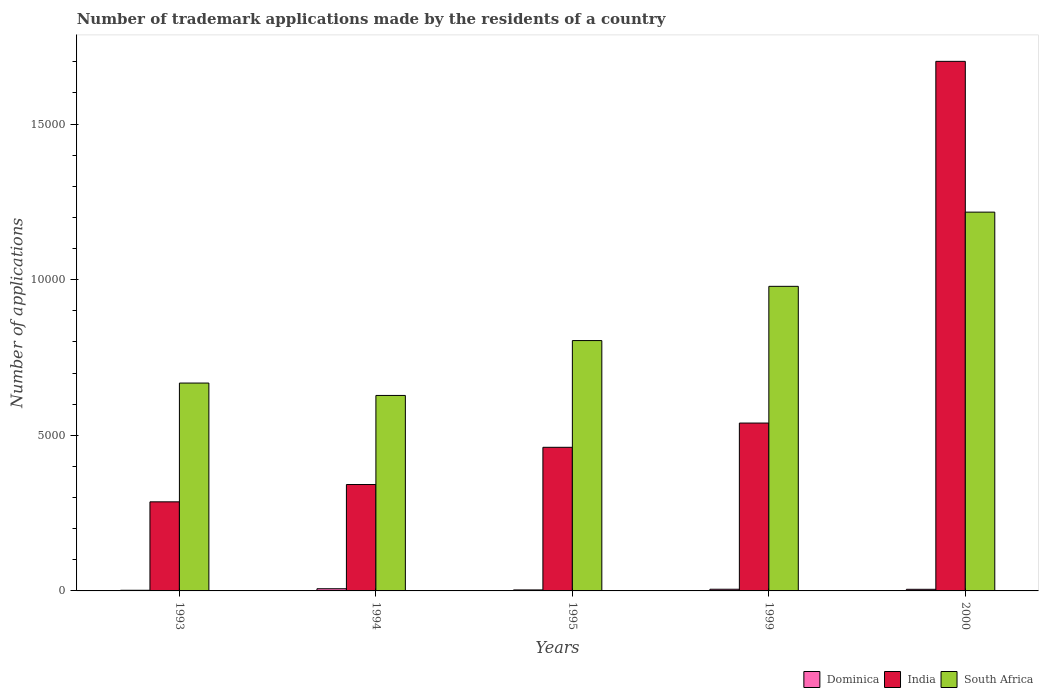How many groups of bars are there?
Offer a terse response. 5. Are the number of bars per tick equal to the number of legend labels?
Your response must be concise. Yes. Are the number of bars on each tick of the X-axis equal?
Your response must be concise. Yes. How many bars are there on the 3rd tick from the left?
Provide a succinct answer. 3. How many bars are there on the 5th tick from the right?
Your response must be concise. 3. What is the label of the 4th group of bars from the left?
Ensure brevity in your answer.  1999. What is the number of trademark applications made by the residents in India in 1995?
Your answer should be very brief. 4614. Across all years, what is the maximum number of trademark applications made by the residents in India?
Provide a succinct answer. 1.70e+04. Across all years, what is the minimum number of trademark applications made by the residents in Dominica?
Your answer should be very brief. 21. What is the total number of trademark applications made by the residents in India in the graph?
Keep it short and to the point. 3.33e+04. What is the difference between the number of trademark applications made by the residents in India in 1994 and that in 2000?
Keep it short and to the point. -1.36e+04. What is the difference between the number of trademark applications made by the residents in South Africa in 1993 and the number of trademark applications made by the residents in India in 1994?
Offer a terse response. 3260. What is the average number of trademark applications made by the residents in Dominica per year?
Give a very brief answer. 45.8. In the year 1994, what is the difference between the number of trademark applications made by the residents in India and number of trademark applications made by the residents in South Africa?
Keep it short and to the point. -2862. Is the number of trademark applications made by the residents in India in 1999 less than that in 2000?
Your answer should be compact. Yes. What is the difference between the highest and the second highest number of trademark applications made by the residents in India?
Make the answer very short. 1.16e+04. In how many years, is the number of trademark applications made by the residents in South Africa greater than the average number of trademark applications made by the residents in South Africa taken over all years?
Offer a very short reply. 2. Is the sum of the number of trademark applications made by the residents in South Africa in 1995 and 1999 greater than the maximum number of trademark applications made by the residents in India across all years?
Ensure brevity in your answer.  Yes. What does the 3rd bar from the right in 1999 represents?
Offer a terse response. Dominica. How many bars are there?
Your answer should be compact. 15. Are all the bars in the graph horizontal?
Offer a very short reply. No. How many years are there in the graph?
Your answer should be very brief. 5. Does the graph contain any zero values?
Offer a very short reply. No. Does the graph contain grids?
Provide a short and direct response. No. Where does the legend appear in the graph?
Your answer should be very brief. Bottom right. How are the legend labels stacked?
Give a very brief answer. Horizontal. What is the title of the graph?
Your answer should be compact. Number of trademark applications made by the residents of a country. Does "Libya" appear as one of the legend labels in the graph?
Ensure brevity in your answer.  No. What is the label or title of the Y-axis?
Keep it short and to the point. Number of applications. What is the Number of applications in Dominica in 1993?
Your answer should be very brief. 21. What is the Number of applications of India in 1993?
Give a very brief answer. 2862. What is the Number of applications in South Africa in 1993?
Ensure brevity in your answer.  6678. What is the Number of applications in India in 1994?
Make the answer very short. 3418. What is the Number of applications of South Africa in 1994?
Ensure brevity in your answer.  6280. What is the Number of applications in India in 1995?
Give a very brief answer. 4614. What is the Number of applications in South Africa in 1995?
Provide a succinct answer. 8043. What is the Number of applications in India in 1999?
Provide a short and direct response. 5393. What is the Number of applications of South Africa in 1999?
Keep it short and to the point. 9785. What is the Number of applications in Dominica in 2000?
Offer a terse response. 52. What is the Number of applications of India in 2000?
Keep it short and to the point. 1.70e+04. What is the Number of applications in South Africa in 2000?
Make the answer very short. 1.22e+04. Across all years, what is the maximum Number of applications in Dominica?
Keep it short and to the point. 70. Across all years, what is the maximum Number of applications of India?
Offer a very short reply. 1.70e+04. Across all years, what is the maximum Number of applications in South Africa?
Your answer should be compact. 1.22e+04. Across all years, what is the minimum Number of applications of Dominica?
Your answer should be compact. 21. Across all years, what is the minimum Number of applications in India?
Ensure brevity in your answer.  2862. Across all years, what is the minimum Number of applications of South Africa?
Provide a short and direct response. 6280. What is the total Number of applications in Dominica in the graph?
Make the answer very short. 229. What is the total Number of applications of India in the graph?
Keep it short and to the point. 3.33e+04. What is the total Number of applications in South Africa in the graph?
Provide a succinct answer. 4.30e+04. What is the difference between the Number of applications in Dominica in 1993 and that in 1994?
Your answer should be compact. -49. What is the difference between the Number of applications in India in 1993 and that in 1994?
Your response must be concise. -556. What is the difference between the Number of applications of South Africa in 1993 and that in 1994?
Your response must be concise. 398. What is the difference between the Number of applications in Dominica in 1993 and that in 1995?
Make the answer very short. -11. What is the difference between the Number of applications of India in 1993 and that in 1995?
Keep it short and to the point. -1752. What is the difference between the Number of applications of South Africa in 1993 and that in 1995?
Provide a succinct answer. -1365. What is the difference between the Number of applications in Dominica in 1993 and that in 1999?
Make the answer very short. -33. What is the difference between the Number of applications of India in 1993 and that in 1999?
Provide a short and direct response. -2531. What is the difference between the Number of applications in South Africa in 1993 and that in 1999?
Give a very brief answer. -3107. What is the difference between the Number of applications of Dominica in 1993 and that in 2000?
Your answer should be compact. -31. What is the difference between the Number of applications of India in 1993 and that in 2000?
Offer a terse response. -1.42e+04. What is the difference between the Number of applications in South Africa in 1993 and that in 2000?
Ensure brevity in your answer.  -5491. What is the difference between the Number of applications in Dominica in 1994 and that in 1995?
Keep it short and to the point. 38. What is the difference between the Number of applications in India in 1994 and that in 1995?
Keep it short and to the point. -1196. What is the difference between the Number of applications of South Africa in 1994 and that in 1995?
Ensure brevity in your answer.  -1763. What is the difference between the Number of applications in Dominica in 1994 and that in 1999?
Your response must be concise. 16. What is the difference between the Number of applications in India in 1994 and that in 1999?
Your answer should be compact. -1975. What is the difference between the Number of applications of South Africa in 1994 and that in 1999?
Offer a very short reply. -3505. What is the difference between the Number of applications of Dominica in 1994 and that in 2000?
Your answer should be very brief. 18. What is the difference between the Number of applications in India in 1994 and that in 2000?
Keep it short and to the point. -1.36e+04. What is the difference between the Number of applications in South Africa in 1994 and that in 2000?
Make the answer very short. -5889. What is the difference between the Number of applications of India in 1995 and that in 1999?
Give a very brief answer. -779. What is the difference between the Number of applications in South Africa in 1995 and that in 1999?
Provide a short and direct response. -1742. What is the difference between the Number of applications of Dominica in 1995 and that in 2000?
Give a very brief answer. -20. What is the difference between the Number of applications in India in 1995 and that in 2000?
Ensure brevity in your answer.  -1.24e+04. What is the difference between the Number of applications of South Africa in 1995 and that in 2000?
Your answer should be very brief. -4126. What is the difference between the Number of applications of India in 1999 and that in 2000?
Keep it short and to the point. -1.16e+04. What is the difference between the Number of applications of South Africa in 1999 and that in 2000?
Keep it short and to the point. -2384. What is the difference between the Number of applications of Dominica in 1993 and the Number of applications of India in 1994?
Keep it short and to the point. -3397. What is the difference between the Number of applications in Dominica in 1993 and the Number of applications in South Africa in 1994?
Keep it short and to the point. -6259. What is the difference between the Number of applications in India in 1993 and the Number of applications in South Africa in 1994?
Provide a short and direct response. -3418. What is the difference between the Number of applications in Dominica in 1993 and the Number of applications in India in 1995?
Give a very brief answer. -4593. What is the difference between the Number of applications in Dominica in 1993 and the Number of applications in South Africa in 1995?
Your response must be concise. -8022. What is the difference between the Number of applications of India in 1993 and the Number of applications of South Africa in 1995?
Ensure brevity in your answer.  -5181. What is the difference between the Number of applications in Dominica in 1993 and the Number of applications in India in 1999?
Give a very brief answer. -5372. What is the difference between the Number of applications in Dominica in 1993 and the Number of applications in South Africa in 1999?
Your answer should be very brief. -9764. What is the difference between the Number of applications in India in 1993 and the Number of applications in South Africa in 1999?
Offer a terse response. -6923. What is the difference between the Number of applications in Dominica in 1993 and the Number of applications in India in 2000?
Offer a terse response. -1.70e+04. What is the difference between the Number of applications in Dominica in 1993 and the Number of applications in South Africa in 2000?
Provide a succinct answer. -1.21e+04. What is the difference between the Number of applications in India in 1993 and the Number of applications in South Africa in 2000?
Ensure brevity in your answer.  -9307. What is the difference between the Number of applications in Dominica in 1994 and the Number of applications in India in 1995?
Your answer should be very brief. -4544. What is the difference between the Number of applications of Dominica in 1994 and the Number of applications of South Africa in 1995?
Your answer should be compact. -7973. What is the difference between the Number of applications of India in 1994 and the Number of applications of South Africa in 1995?
Keep it short and to the point. -4625. What is the difference between the Number of applications in Dominica in 1994 and the Number of applications in India in 1999?
Your answer should be very brief. -5323. What is the difference between the Number of applications in Dominica in 1994 and the Number of applications in South Africa in 1999?
Keep it short and to the point. -9715. What is the difference between the Number of applications of India in 1994 and the Number of applications of South Africa in 1999?
Provide a short and direct response. -6367. What is the difference between the Number of applications in Dominica in 1994 and the Number of applications in India in 2000?
Offer a very short reply. -1.69e+04. What is the difference between the Number of applications of Dominica in 1994 and the Number of applications of South Africa in 2000?
Your answer should be compact. -1.21e+04. What is the difference between the Number of applications of India in 1994 and the Number of applications of South Africa in 2000?
Your answer should be very brief. -8751. What is the difference between the Number of applications in Dominica in 1995 and the Number of applications in India in 1999?
Your response must be concise. -5361. What is the difference between the Number of applications of Dominica in 1995 and the Number of applications of South Africa in 1999?
Give a very brief answer. -9753. What is the difference between the Number of applications of India in 1995 and the Number of applications of South Africa in 1999?
Make the answer very short. -5171. What is the difference between the Number of applications in Dominica in 1995 and the Number of applications in India in 2000?
Offer a terse response. -1.70e+04. What is the difference between the Number of applications in Dominica in 1995 and the Number of applications in South Africa in 2000?
Provide a short and direct response. -1.21e+04. What is the difference between the Number of applications in India in 1995 and the Number of applications in South Africa in 2000?
Provide a succinct answer. -7555. What is the difference between the Number of applications of Dominica in 1999 and the Number of applications of India in 2000?
Your answer should be very brief. -1.70e+04. What is the difference between the Number of applications of Dominica in 1999 and the Number of applications of South Africa in 2000?
Your response must be concise. -1.21e+04. What is the difference between the Number of applications in India in 1999 and the Number of applications in South Africa in 2000?
Provide a short and direct response. -6776. What is the average Number of applications of Dominica per year?
Keep it short and to the point. 45.8. What is the average Number of applications of India per year?
Ensure brevity in your answer.  6660. What is the average Number of applications in South Africa per year?
Keep it short and to the point. 8591. In the year 1993, what is the difference between the Number of applications of Dominica and Number of applications of India?
Give a very brief answer. -2841. In the year 1993, what is the difference between the Number of applications in Dominica and Number of applications in South Africa?
Ensure brevity in your answer.  -6657. In the year 1993, what is the difference between the Number of applications of India and Number of applications of South Africa?
Your answer should be compact. -3816. In the year 1994, what is the difference between the Number of applications in Dominica and Number of applications in India?
Offer a very short reply. -3348. In the year 1994, what is the difference between the Number of applications of Dominica and Number of applications of South Africa?
Provide a short and direct response. -6210. In the year 1994, what is the difference between the Number of applications in India and Number of applications in South Africa?
Offer a very short reply. -2862. In the year 1995, what is the difference between the Number of applications in Dominica and Number of applications in India?
Offer a terse response. -4582. In the year 1995, what is the difference between the Number of applications in Dominica and Number of applications in South Africa?
Your answer should be very brief. -8011. In the year 1995, what is the difference between the Number of applications of India and Number of applications of South Africa?
Offer a terse response. -3429. In the year 1999, what is the difference between the Number of applications in Dominica and Number of applications in India?
Your response must be concise. -5339. In the year 1999, what is the difference between the Number of applications of Dominica and Number of applications of South Africa?
Offer a terse response. -9731. In the year 1999, what is the difference between the Number of applications in India and Number of applications in South Africa?
Provide a succinct answer. -4392. In the year 2000, what is the difference between the Number of applications in Dominica and Number of applications in India?
Provide a succinct answer. -1.70e+04. In the year 2000, what is the difference between the Number of applications in Dominica and Number of applications in South Africa?
Offer a terse response. -1.21e+04. In the year 2000, what is the difference between the Number of applications of India and Number of applications of South Africa?
Make the answer very short. 4844. What is the ratio of the Number of applications in India in 1993 to that in 1994?
Give a very brief answer. 0.84. What is the ratio of the Number of applications of South Africa in 1993 to that in 1994?
Your answer should be compact. 1.06. What is the ratio of the Number of applications of Dominica in 1993 to that in 1995?
Give a very brief answer. 0.66. What is the ratio of the Number of applications of India in 1993 to that in 1995?
Offer a terse response. 0.62. What is the ratio of the Number of applications of South Africa in 1993 to that in 1995?
Give a very brief answer. 0.83. What is the ratio of the Number of applications of Dominica in 1993 to that in 1999?
Your response must be concise. 0.39. What is the ratio of the Number of applications of India in 1993 to that in 1999?
Your response must be concise. 0.53. What is the ratio of the Number of applications in South Africa in 1993 to that in 1999?
Offer a terse response. 0.68. What is the ratio of the Number of applications in Dominica in 1993 to that in 2000?
Give a very brief answer. 0.4. What is the ratio of the Number of applications of India in 1993 to that in 2000?
Keep it short and to the point. 0.17. What is the ratio of the Number of applications of South Africa in 1993 to that in 2000?
Your answer should be compact. 0.55. What is the ratio of the Number of applications in Dominica in 1994 to that in 1995?
Your response must be concise. 2.19. What is the ratio of the Number of applications in India in 1994 to that in 1995?
Offer a very short reply. 0.74. What is the ratio of the Number of applications of South Africa in 1994 to that in 1995?
Keep it short and to the point. 0.78. What is the ratio of the Number of applications of Dominica in 1994 to that in 1999?
Offer a very short reply. 1.3. What is the ratio of the Number of applications of India in 1994 to that in 1999?
Provide a short and direct response. 0.63. What is the ratio of the Number of applications in South Africa in 1994 to that in 1999?
Keep it short and to the point. 0.64. What is the ratio of the Number of applications of Dominica in 1994 to that in 2000?
Ensure brevity in your answer.  1.35. What is the ratio of the Number of applications in India in 1994 to that in 2000?
Offer a terse response. 0.2. What is the ratio of the Number of applications of South Africa in 1994 to that in 2000?
Your answer should be compact. 0.52. What is the ratio of the Number of applications in Dominica in 1995 to that in 1999?
Keep it short and to the point. 0.59. What is the ratio of the Number of applications of India in 1995 to that in 1999?
Your answer should be very brief. 0.86. What is the ratio of the Number of applications of South Africa in 1995 to that in 1999?
Make the answer very short. 0.82. What is the ratio of the Number of applications of Dominica in 1995 to that in 2000?
Your answer should be very brief. 0.62. What is the ratio of the Number of applications of India in 1995 to that in 2000?
Ensure brevity in your answer.  0.27. What is the ratio of the Number of applications of South Africa in 1995 to that in 2000?
Give a very brief answer. 0.66. What is the ratio of the Number of applications of Dominica in 1999 to that in 2000?
Provide a short and direct response. 1.04. What is the ratio of the Number of applications of India in 1999 to that in 2000?
Your answer should be compact. 0.32. What is the ratio of the Number of applications of South Africa in 1999 to that in 2000?
Ensure brevity in your answer.  0.8. What is the difference between the highest and the second highest Number of applications in India?
Your response must be concise. 1.16e+04. What is the difference between the highest and the second highest Number of applications of South Africa?
Your response must be concise. 2384. What is the difference between the highest and the lowest Number of applications in India?
Give a very brief answer. 1.42e+04. What is the difference between the highest and the lowest Number of applications in South Africa?
Ensure brevity in your answer.  5889. 